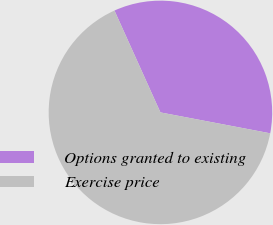Convert chart. <chart><loc_0><loc_0><loc_500><loc_500><pie_chart><fcel>Options granted to existing<fcel>Exercise price<nl><fcel>34.74%<fcel>65.26%<nl></chart> 